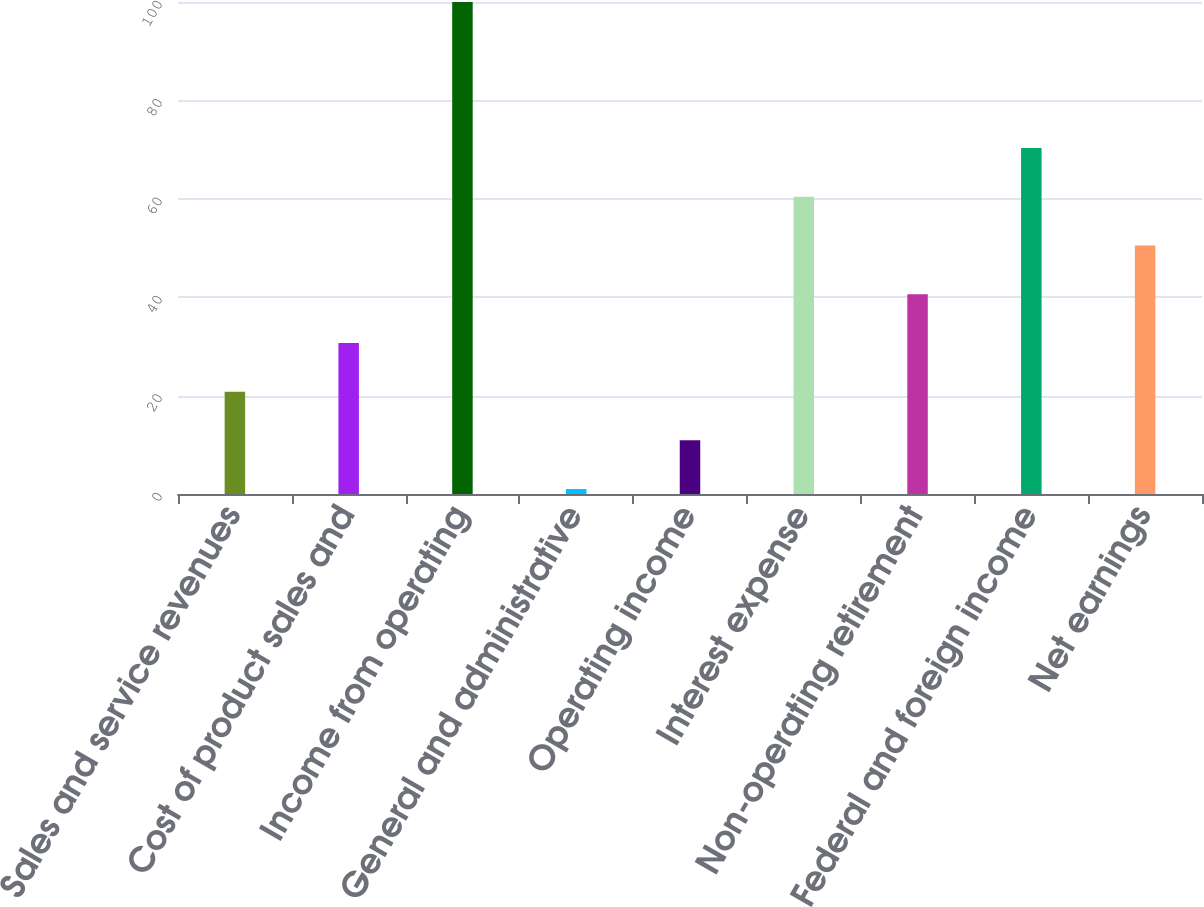<chart> <loc_0><loc_0><loc_500><loc_500><bar_chart><fcel>Sales and service revenues<fcel>Cost of product sales and<fcel>Income from operating<fcel>General and administrative<fcel>Operating income<fcel>Interest expense<fcel>Non-operating retirement<fcel>Federal and foreign income<fcel>Net earnings<nl><fcel>20.8<fcel>30.7<fcel>100<fcel>1<fcel>10.9<fcel>60.4<fcel>40.6<fcel>70.3<fcel>50.5<nl></chart> 